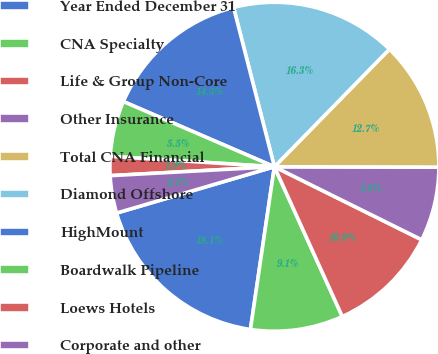Convert chart to OTSL. <chart><loc_0><loc_0><loc_500><loc_500><pie_chart><fcel>Year Ended December 31<fcel>CNA Specialty<fcel>Life & Group Non-Core<fcel>Other Insurance<fcel>Total CNA Financial<fcel>Diamond Offshore<fcel>HighMount<fcel>Boardwalk Pipeline<fcel>Loews Hotels<fcel>Corporate and other<nl><fcel>18.13%<fcel>9.1%<fcel>10.9%<fcel>7.29%<fcel>12.71%<fcel>16.32%<fcel>14.52%<fcel>5.48%<fcel>1.87%<fcel>3.68%<nl></chart> 